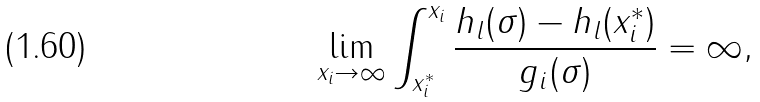Convert formula to latex. <formula><loc_0><loc_0><loc_500><loc_500>\lim _ { x _ { i } \rightarrow \infty } \int _ { x _ { i } ^ { * } } ^ { x _ { i } } \frac { h _ { l } ( \sigma ) - h _ { l } ( x _ { i } ^ { * } ) } { g _ { i } ( \sigma ) } = \infty ,</formula> 